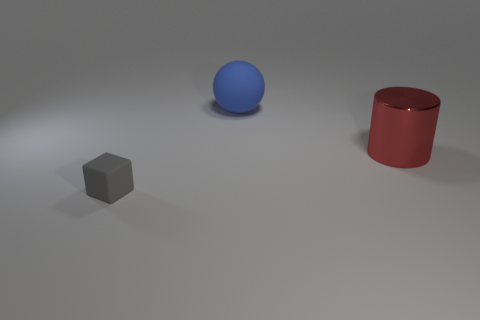The object that is left of the metal object and behind the small rubber object is what color? The object situated to the left of the metallic item, presumed to be the blue sphere, and behind what appears to be a smaller rubber element — a gray cube — is indeed blue. It's a rich, matte blue, consistent with the characteristic hue of a rubber sphere often used in simple color and material demonstrations. 